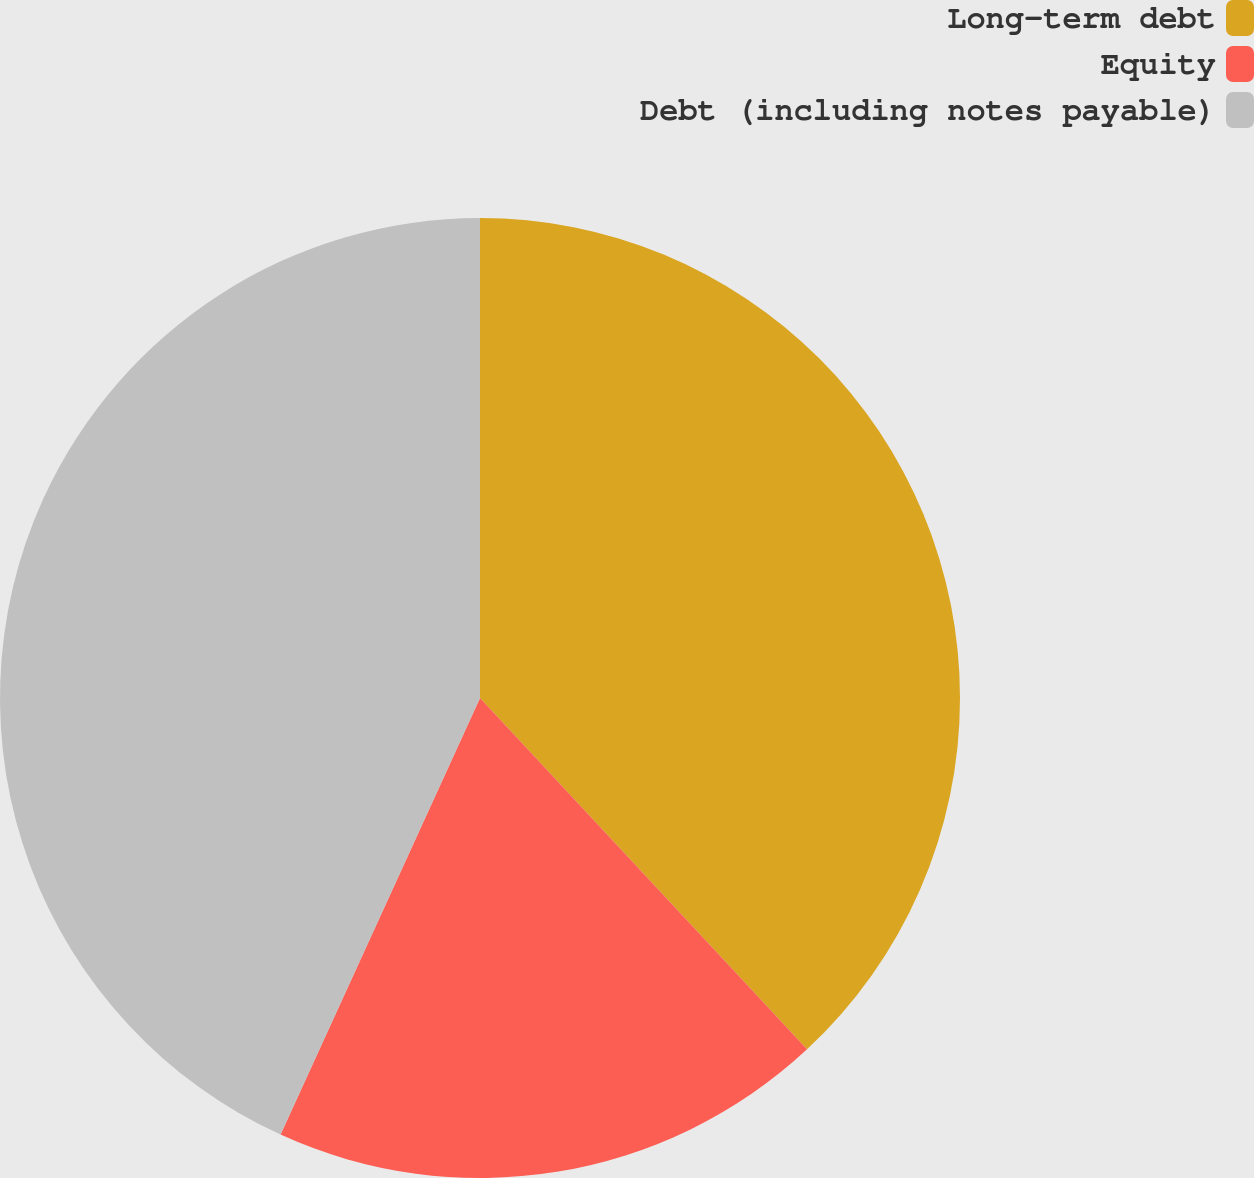Convert chart. <chart><loc_0><loc_0><loc_500><loc_500><pie_chart><fcel>Long-term debt<fcel>Equity<fcel>Debt (including notes payable)<nl><fcel>38.07%<fcel>18.75%<fcel>43.18%<nl></chart> 